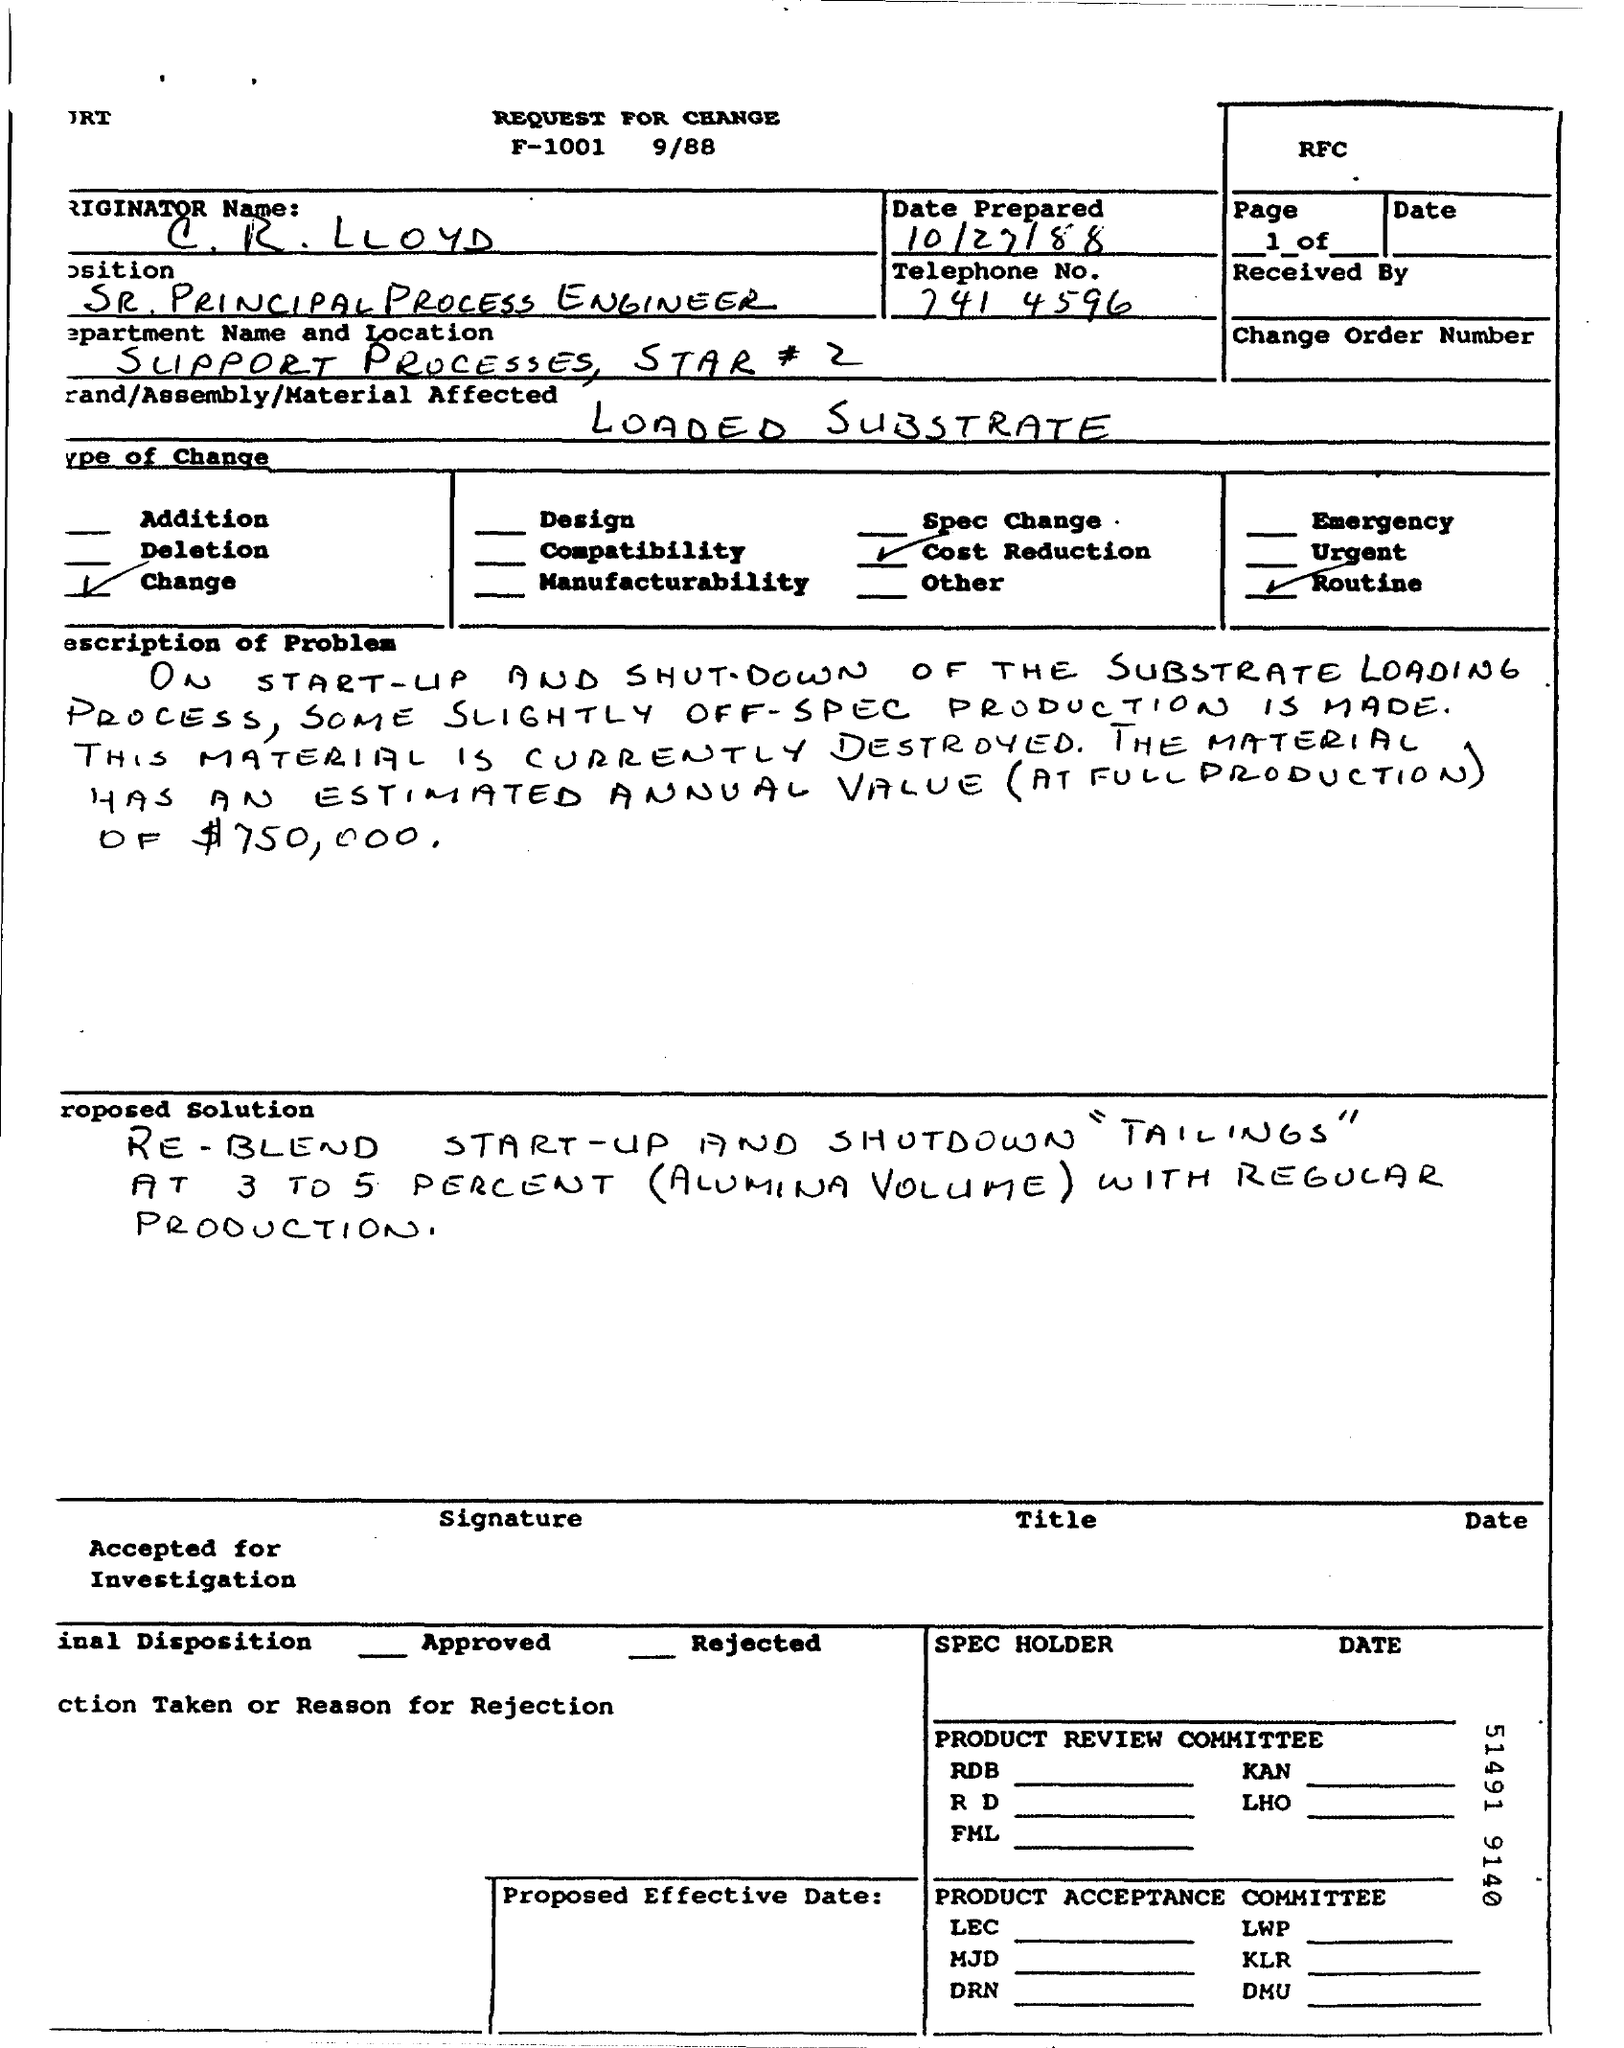List a handful of essential elements in this visual. The position mentioned in the document is that of a Sr. principal process engineer. The name mentioned in the document is C.R.Lloyd. The telephone number provided in the document is 741-4596. The material that is affected in the document is the loaded substrate. The document was prepared on October 27, 1988. 